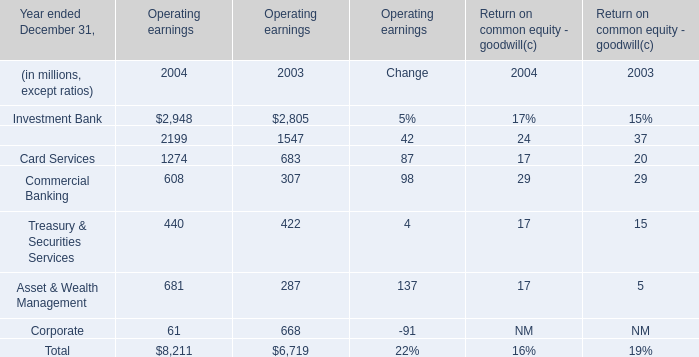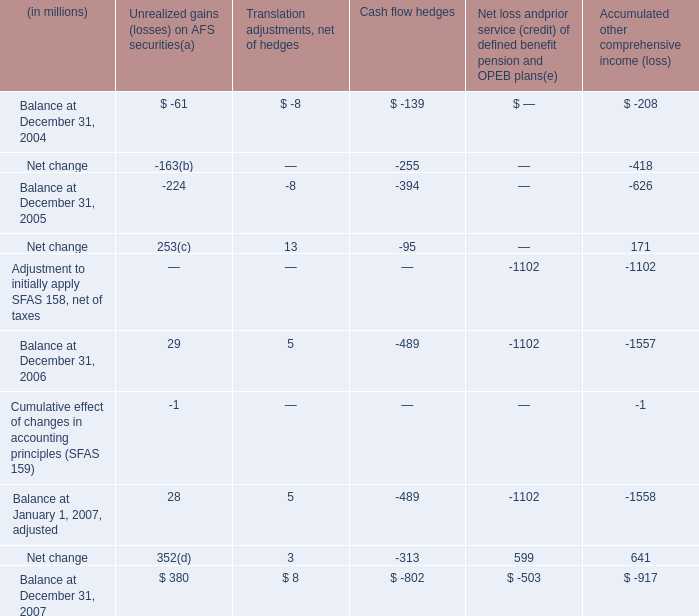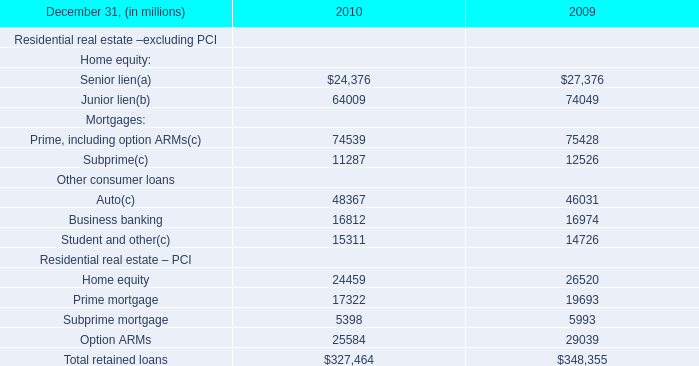What is the ratio of Card Services to the total in 2003 for Operating earnings? 
Computations: (683 / 6719)
Answer: 0.10165. 